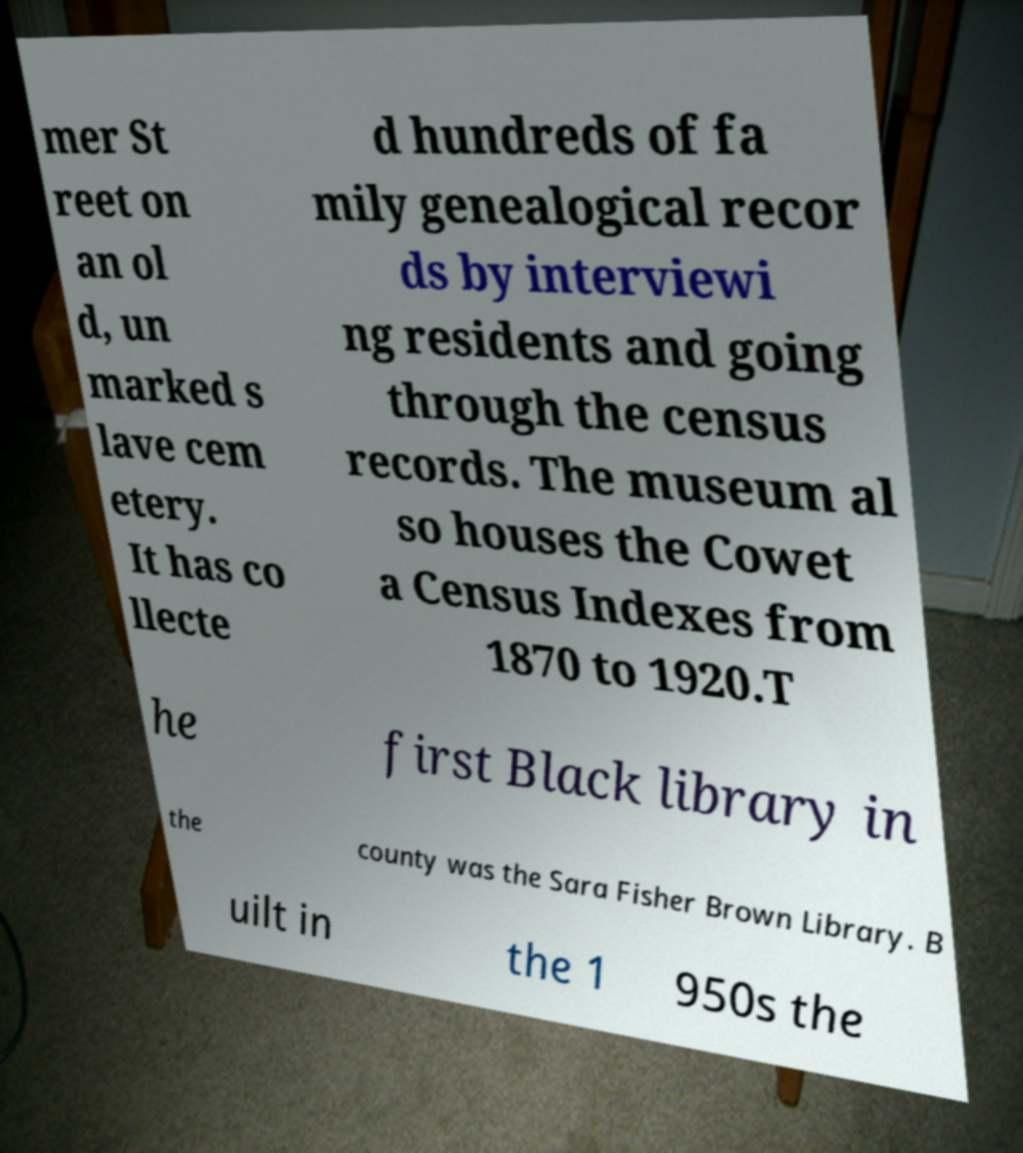Can you accurately transcribe the text from the provided image for me? mer St reet on an ol d, un marked s lave cem etery. It has co llecte d hundreds of fa mily genealogical recor ds by interviewi ng residents and going through the census records. The museum al so houses the Cowet a Census Indexes from 1870 to 1920.T he first Black library in the county was the Sara Fisher Brown Library. B uilt in the 1 950s the 